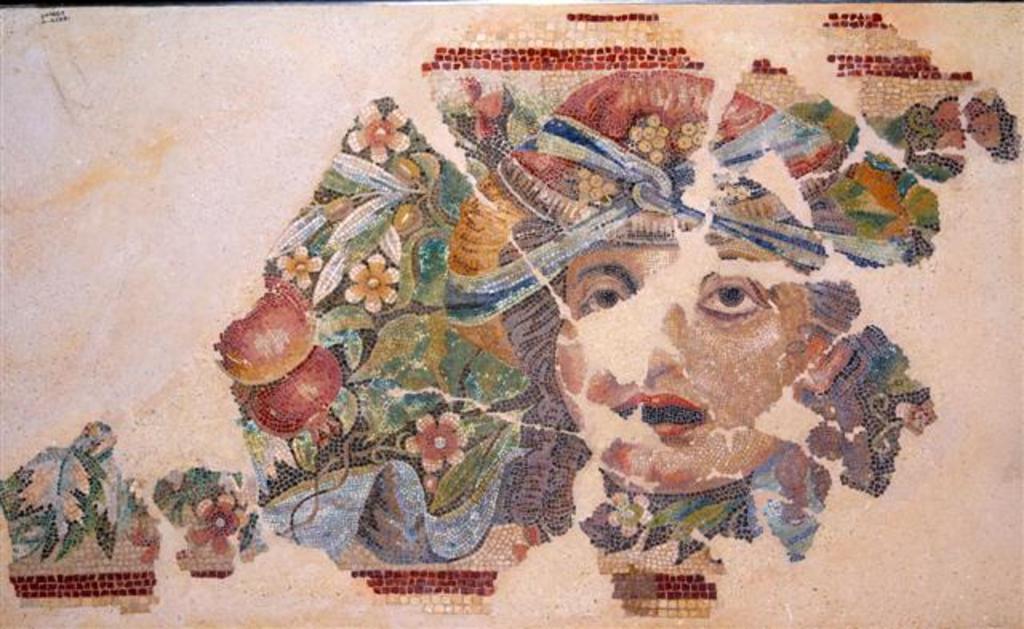Please provide a concise description of this image. In this image there is a painting of the person on a paper. 